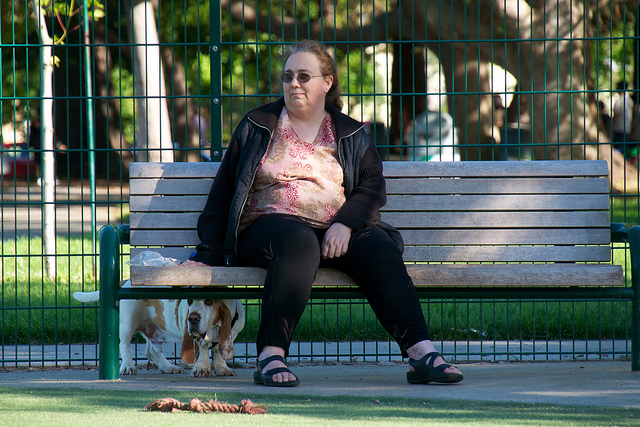Are there any other objects in the scene that give us more context about what's happening? Yes, there are several toys scattered on the ground inside the dog play area, suggesting that the dog may have been playing or is still playing, indicating an active play session. How does the environment contribute to the mood of the image? The park is filled with lush green trees and well-kept grass, giving a sense of tranquility and relaxation. The fence provides a safe enclosed space for dogs to play, while people can enjoy the serenity of the park, contributing to a calm and pleasant mood. 